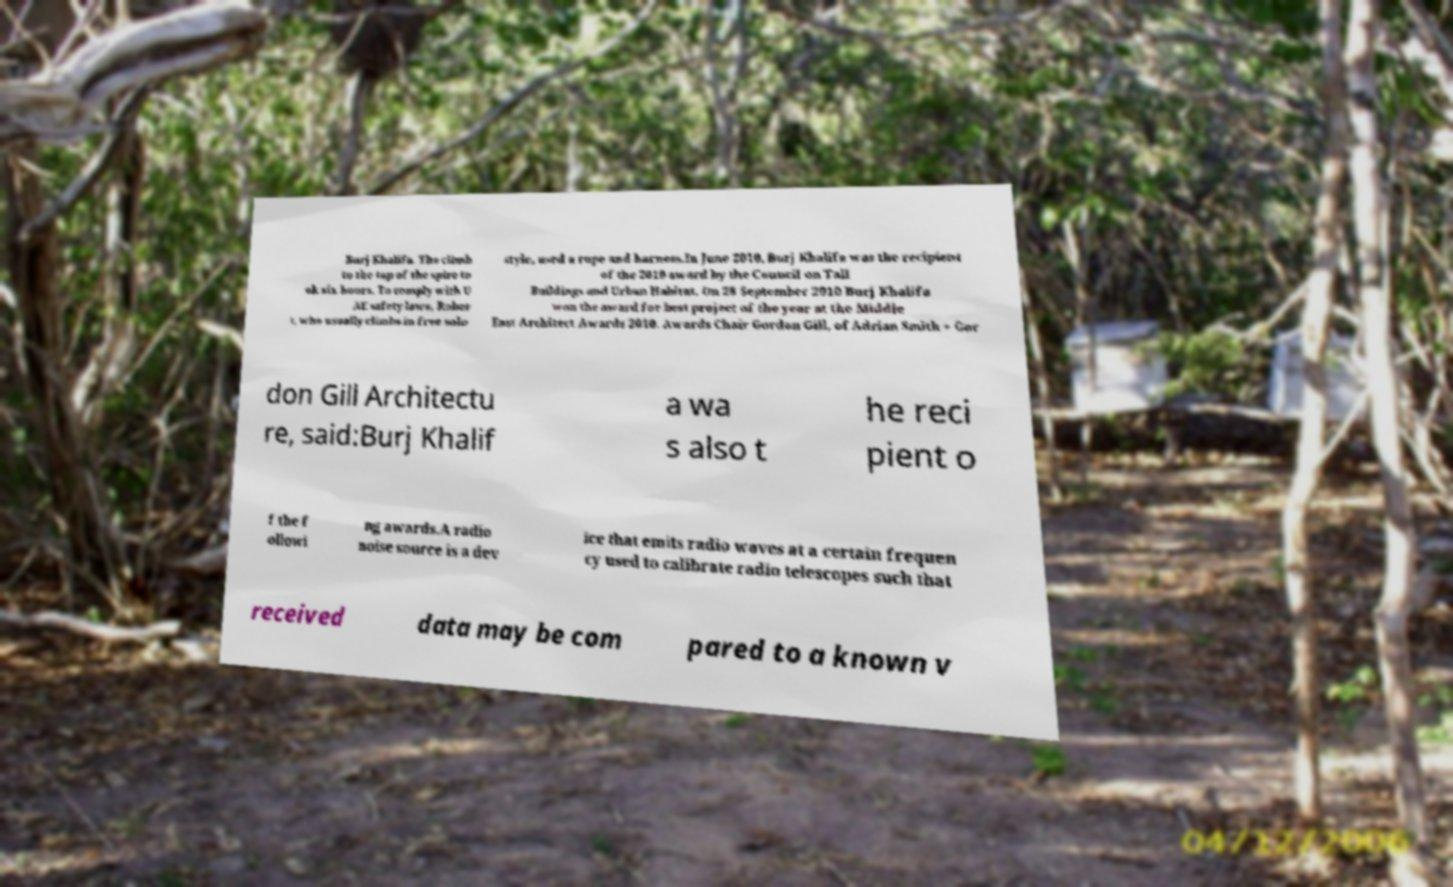Could you extract and type out the text from this image? Burj Khalifa. The climb to the top of the spire to ok six hours. To comply with U AE safety laws, Rober t, who usually climbs in free solo style, used a rope and harness.In June 2010, Burj Khalifa was the recipient of the 2010 award by the Council on Tall Buildings and Urban Habitat. On 28 September 2010 Burj Khalifa won the award for best project of the year at the Middle East Architect Awards 2010. Awards Chair Gordon Gill, of Adrian Smith + Gor don Gill Architectu re, said:Burj Khalif a wa s also t he reci pient o f the f ollowi ng awards.A radio noise source is a dev ice that emits radio waves at a certain frequen cy used to calibrate radio telescopes such that received data may be com pared to a known v 